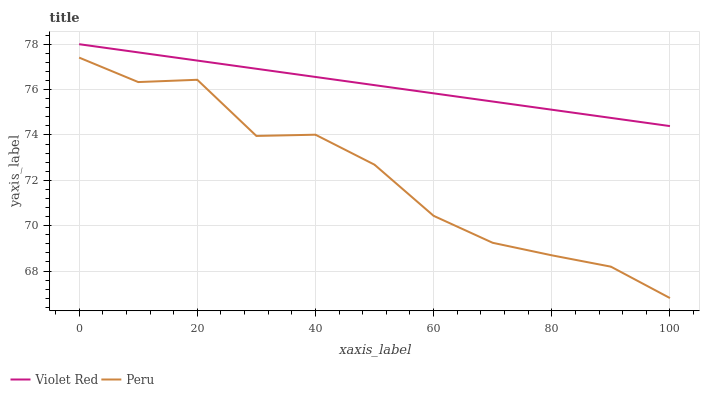Does Peru have the minimum area under the curve?
Answer yes or no. Yes. Does Violet Red have the maximum area under the curve?
Answer yes or no. Yes. Does Peru have the maximum area under the curve?
Answer yes or no. No. Is Violet Red the smoothest?
Answer yes or no. Yes. Is Peru the roughest?
Answer yes or no. Yes. Is Peru the smoothest?
Answer yes or no. No. Does Peru have the lowest value?
Answer yes or no. Yes. Does Violet Red have the highest value?
Answer yes or no. Yes. Does Peru have the highest value?
Answer yes or no. No. Is Peru less than Violet Red?
Answer yes or no. Yes. Is Violet Red greater than Peru?
Answer yes or no. Yes. Does Peru intersect Violet Red?
Answer yes or no. No. 